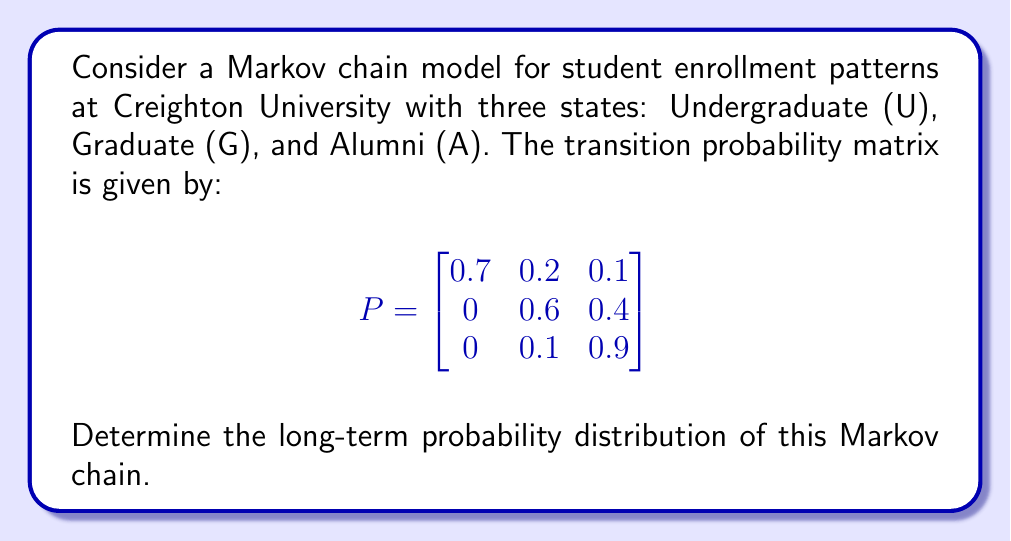Could you help me with this problem? To find the long-term probability distribution, we need to solve for the stationary distribution π = (π₁, π₂, π₃) that satisfies πP = π and π₁ + π₂ + π₃ = 1.

Step 1: Set up the system of equations
$$\begin{align}
0.7π₁ + 0π₂ + 0π₃ &= π₁ \\
0.2π₁ + 0.6π₂ + 0.1π₃ &= π₂ \\
0.1π₁ + 0.4π₂ + 0.9π₃ &= π₃ \\
π₁ + π₂ + π₃ &= 1
\end{align}$$

Step 2: Simplify the equations
$$\begin{align}
-0.3π₁ + 0π₂ + 0π₃ &= 0 \\
0.2π₁ - 0.4π₂ + 0.1π₃ &= 0 \\
0.1π₁ + 0.4π₂ - 0.1π₃ &= 0 \\
π₁ + π₂ + π₃ &= 1
\end{align}$$

Step 3: Solve the system of equations
Using Gaussian elimination or a matrix solver, we get:
$$\begin{align}
π₁ &= \frac{10}{31} ≈ 0.3226 \\
π₂ &= \frac{5}{31} ≈ 0.1613 \\
π₃ &= \frac{16}{31} ≈ 0.5161
\end{align}$$

Step 4: Verify the solution
Check that πP = π:
$$\begin{bmatrix}
\frac{10}{31} & \frac{5}{31} & \frac{16}{31}
\end{bmatrix}
\begin{bmatrix}
0.7 & 0.2 & 0.1 \\
0 & 0.6 & 0.4 \\
0 & 0.1 & 0.9
\end{bmatrix}
= \begin{bmatrix}
\frac{10}{31} & \frac{5}{31} & \frac{16}{31}
\end{bmatrix}$$

The solution satisfies the conditions, so it is the correct long-term probability distribution.
Answer: π = $(\frac{10}{31}, \frac{5}{31}, \frac{16}{31})$ ≈ (0.3226, 0.1613, 0.5161) 